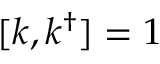<formula> <loc_0><loc_0><loc_500><loc_500>[ k , k ^ { \dagger } ] = 1</formula> 